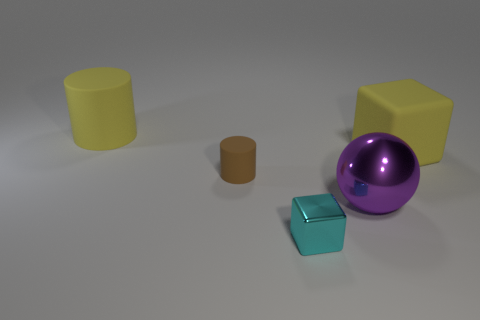How many things are either big purple balls or big yellow objects that are left of the cyan metallic object?
Your answer should be very brief. 2. What is the material of the object that is the same color as the large cylinder?
Your answer should be compact. Rubber. Does the yellow matte thing that is left of the purple thing have the same size as the small cyan thing?
Ensure brevity in your answer.  No. What number of big purple balls are behind the cube that is to the left of the large yellow object right of the small cyan thing?
Offer a terse response. 1. How many cyan things are either big metallic spheres or tiny objects?
Provide a short and direct response. 1. There is a large cube that is the same material as the yellow cylinder; what is its color?
Ensure brevity in your answer.  Yellow. Is there any other thing that has the same size as the cyan shiny block?
Ensure brevity in your answer.  Yes. How many small objects are blocks or rubber things?
Ensure brevity in your answer.  2. Are there fewer tiny objects than rubber things?
Provide a succinct answer. Yes. The other large thing that is the same shape as the cyan thing is what color?
Keep it short and to the point. Yellow. 